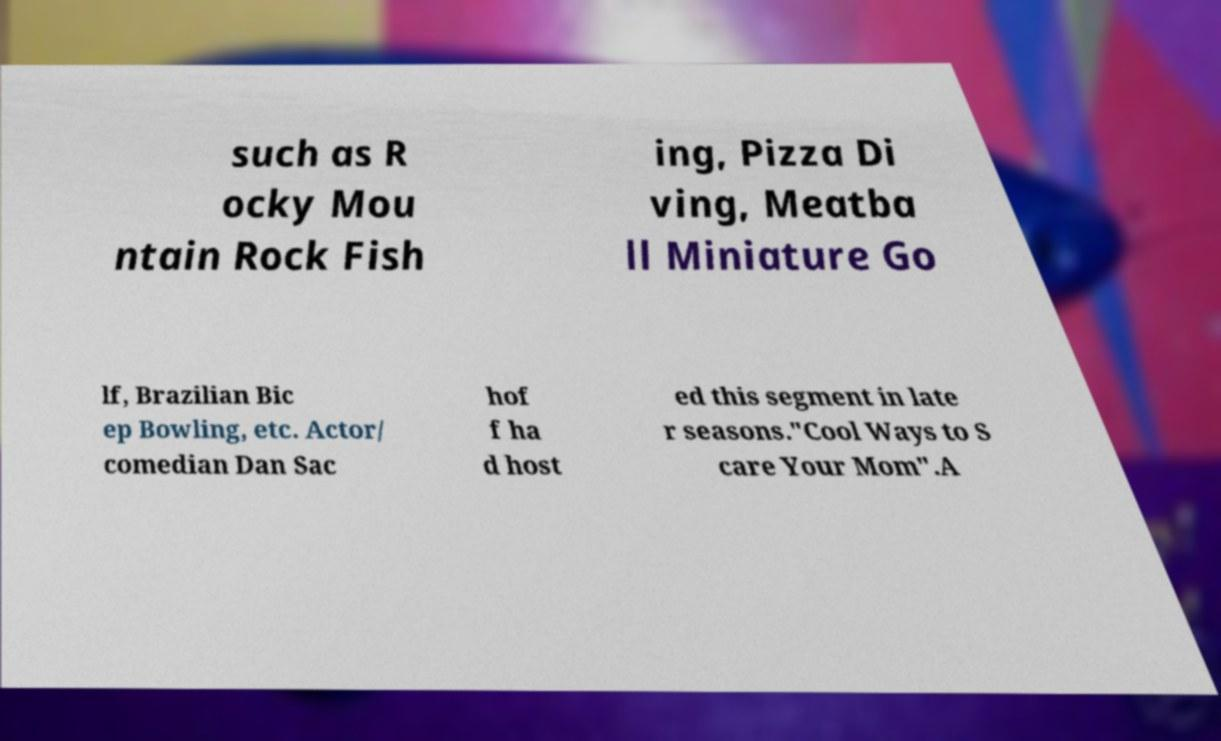Please identify and transcribe the text found in this image. such as R ocky Mou ntain Rock Fish ing, Pizza Di ving, Meatba ll Miniature Go lf, Brazilian Bic ep Bowling, etc. Actor/ comedian Dan Sac hof f ha d host ed this segment in late r seasons."Cool Ways to S care Your Mom".A 